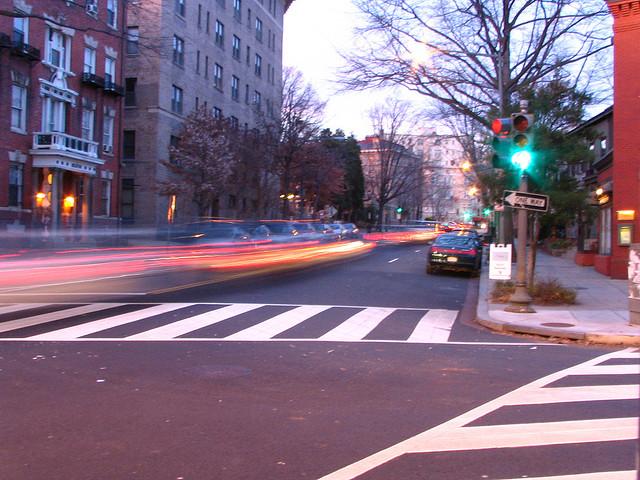Is the traffic going over the speed limit?
Concise answer only. Yes. Is the green light more vibrant because of the camera flash?
Be succinct. Yes. Is this a big city?
Write a very short answer. Yes. 